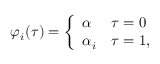Convert formula to latex. <formula><loc_0><loc_0><loc_500><loc_500>\varphi _ { i } ( \tau ) = \left \{ \begin{array} { l l } { \alpha } & { \tau = 0 } \\ { { \alpha _ { i } } } & { \tau = 1 , } \end{array}</formula> 